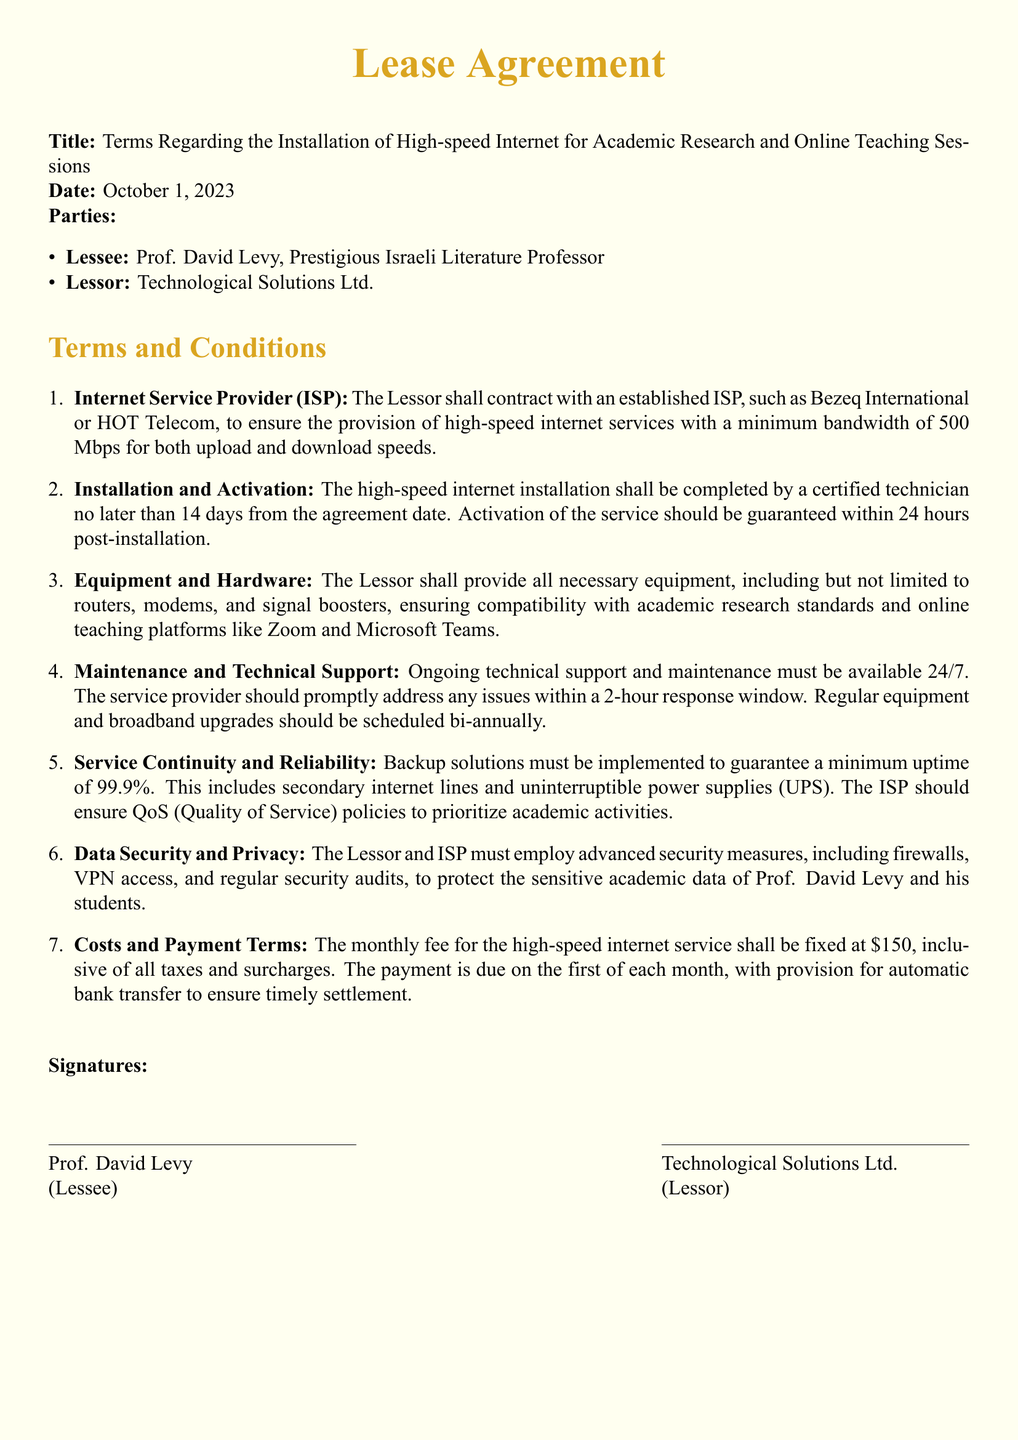What is the minimum bandwidth required for the internet service? The document states that the minimum bandwidth for the high-speed internet service is 500 Mbps for both upload and download speeds.
Answer: 500 Mbps Who is the lessee in this agreement? The lessee is named in the document as Prof. David Levy.
Answer: Prof. David Levy How long does the lessor have to complete the internet installation? The lessor is required to complete the installation within 14 days from the agreement date.
Answer: 14 days What is the monthly fee for the high-speed internet service? The document indicates that the monthly fee for the internet service is fixed at $150, inclusive of all taxes and surcharges.
Answer: $150 What is the uptime guarantee specified in the service continuity terms? The lease agreement states a minimum uptime guarantee of 99.9%.
Answer: 99.9% Which two online teaching platforms are mentioned? The document lists Zoom and Microsoft Teams as platforms compatible with the provided equipment.
Answer: Zoom and Microsoft Teams What is the timeframe for the activation of the internet service after installation? The activation of the internet service is guaranteed within 24 hours post-installation, as per the document.
Answer: 24 hours Which company is listed as the lessor in the agreement? The lessor is identified in the document as Technological Solutions Ltd.
Answer: Technological Solutions Ltd 